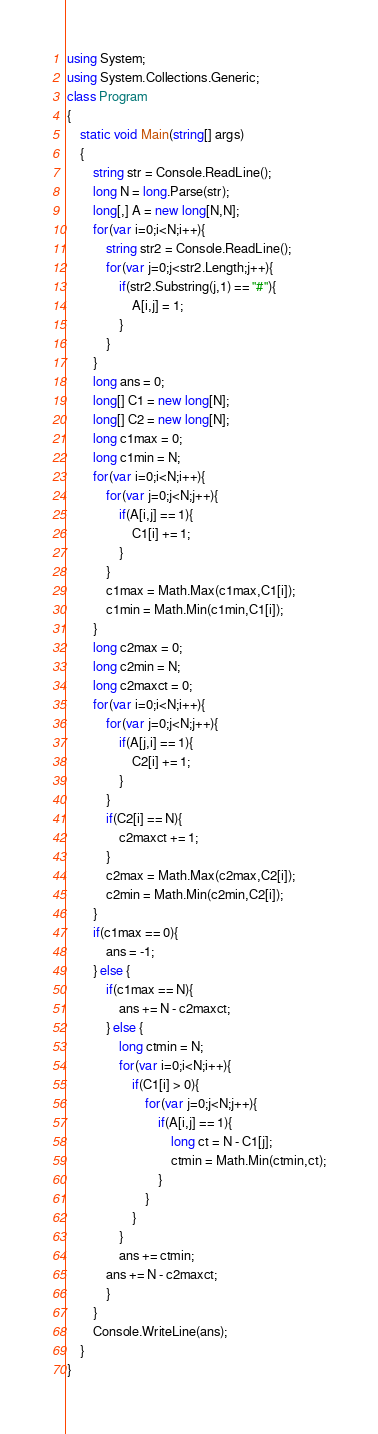<code> <loc_0><loc_0><loc_500><loc_500><_C#_>using System;
using System.Collections.Generic;
class Program
{
	static void Main(string[] args)
	{
		string str = Console.ReadLine();
		long N = long.Parse(str);
		long[,] A = new long[N,N];
		for(var i=0;i<N;i++){
			string str2 = Console.ReadLine();
			for(var j=0;j<str2.Length;j++){
				if(str2.Substring(j,1) == "#"){
					A[i,j] = 1;
				}
			}
		}
		long ans = 0;
		long[] C1 = new long[N];
		long[] C2 = new long[N];
		long c1max = 0;
		long c1min = N;
		for(var i=0;i<N;i++){
			for(var j=0;j<N;j++){
				if(A[i,j] == 1){
					C1[i] += 1;
				}
			}
			c1max = Math.Max(c1max,C1[i]);
			c1min = Math.Min(c1min,C1[i]);
		}
		long c2max = 0;
		long c2min = N;
		long c2maxct = 0;
		for(var i=0;i<N;i++){
			for(var j=0;j<N;j++){
				if(A[j,i] == 1){
					C2[i] += 1;
				}
			}
			if(C2[i] == N){
				c2maxct += 1;
			}
			c2max = Math.Max(c2max,C2[i]);
			c2min = Math.Min(c2min,C2[i]);
		}
		if(c1max == 0){
			ans = -1;
		} else {
			if(c1max == N){
				ans += N - c2maxct;
			} else {
				long ctmin = N;
				for(var i=0;i<N;i++){
					if(C1[i] > 0){
						for(var j=0;j<N;j++){
							if(A[i,j] == 1){
								long ct = N - C1[j];
								ctmin = Math.Min(ctmin,ct);
							}
						}
					}
				}
				ans += ctmin;
			ans += N - c2maxct;
			}
		}
		Console.WriteLine(ans);
	}
}</code> 